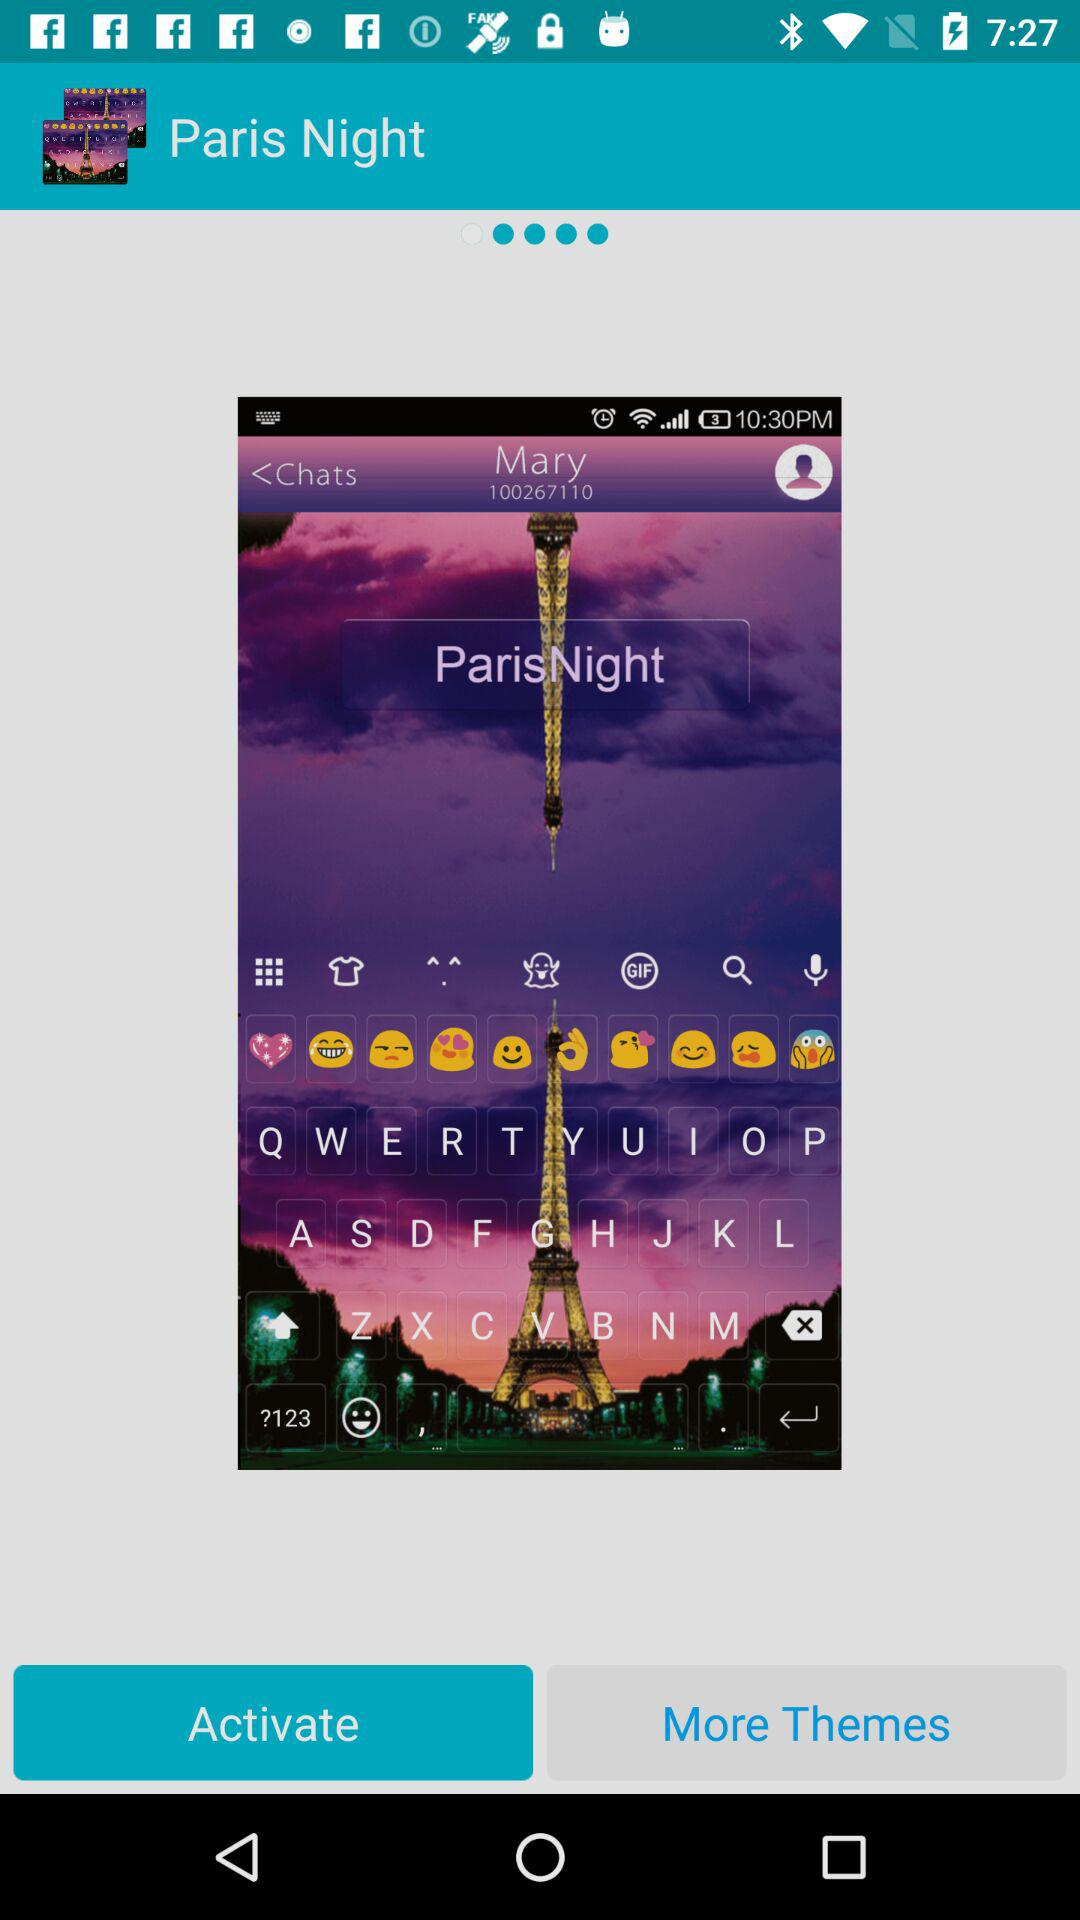What is the name of the user? The user name is Mary. 